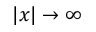<formula> <loc_0><loc_0><loc_500><loc_500>| x | \to \infty</formula> 